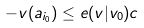<formula> <loc_0><loc_0><loc_500><loc_500>- v ( a _ { i _ { 0 } } ) \leq e ( v | v _ { 0 } ) c</formula> 